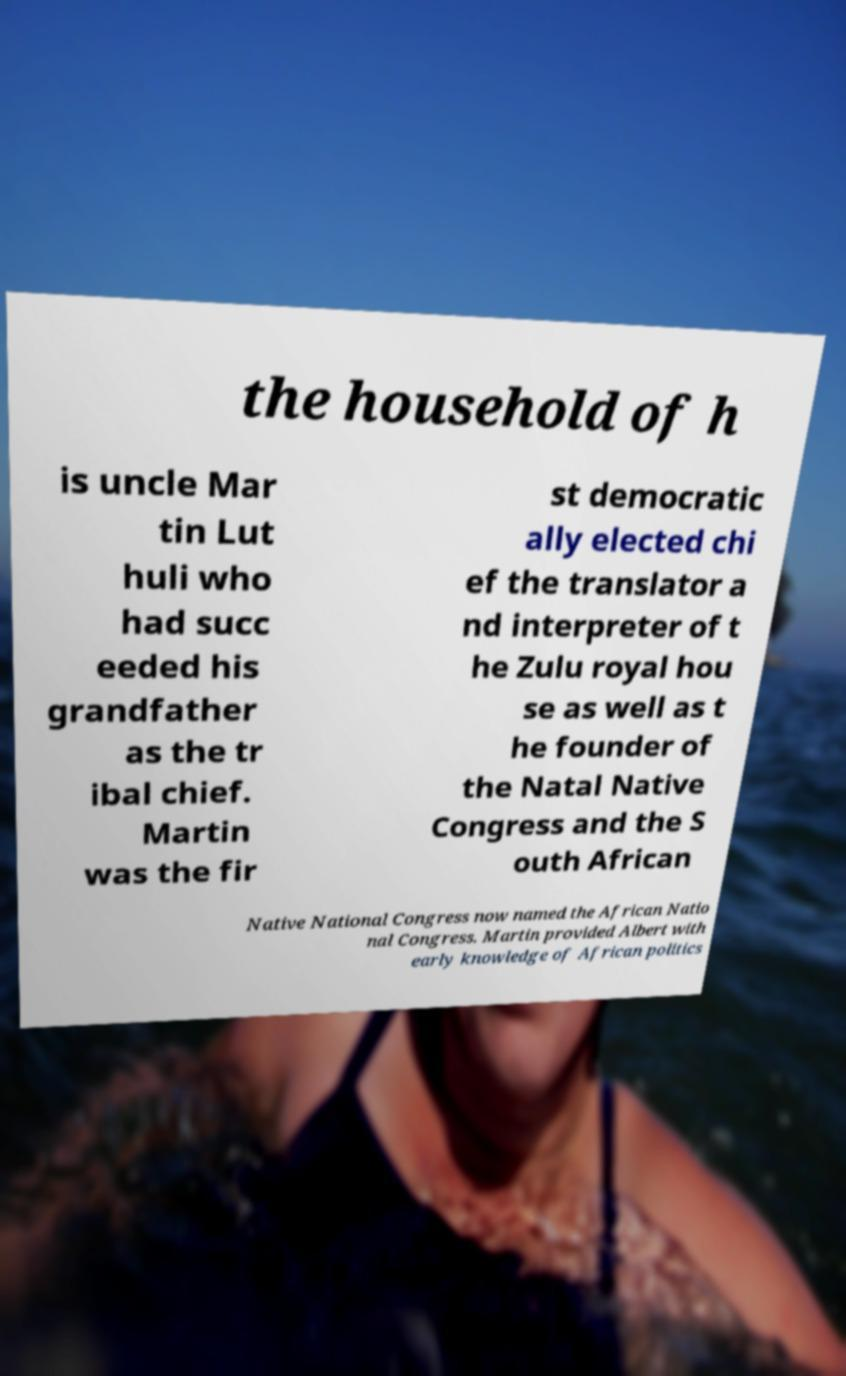I need the written content from this picture converted into text. Can you do that? the household of h is uncle Mar tin Lut huli who had succ eeded his grandfather as the tr ibal chief. Martin was the fir st democratic ally elected chi ef the translator a nd interpreter of t he Zulu royal hou se as well as t he founder of the Natal Native Congress and the S outh African Native National Congress now named the African Natio nal Congress. Martin provided Albert with early knowledge of African politics 